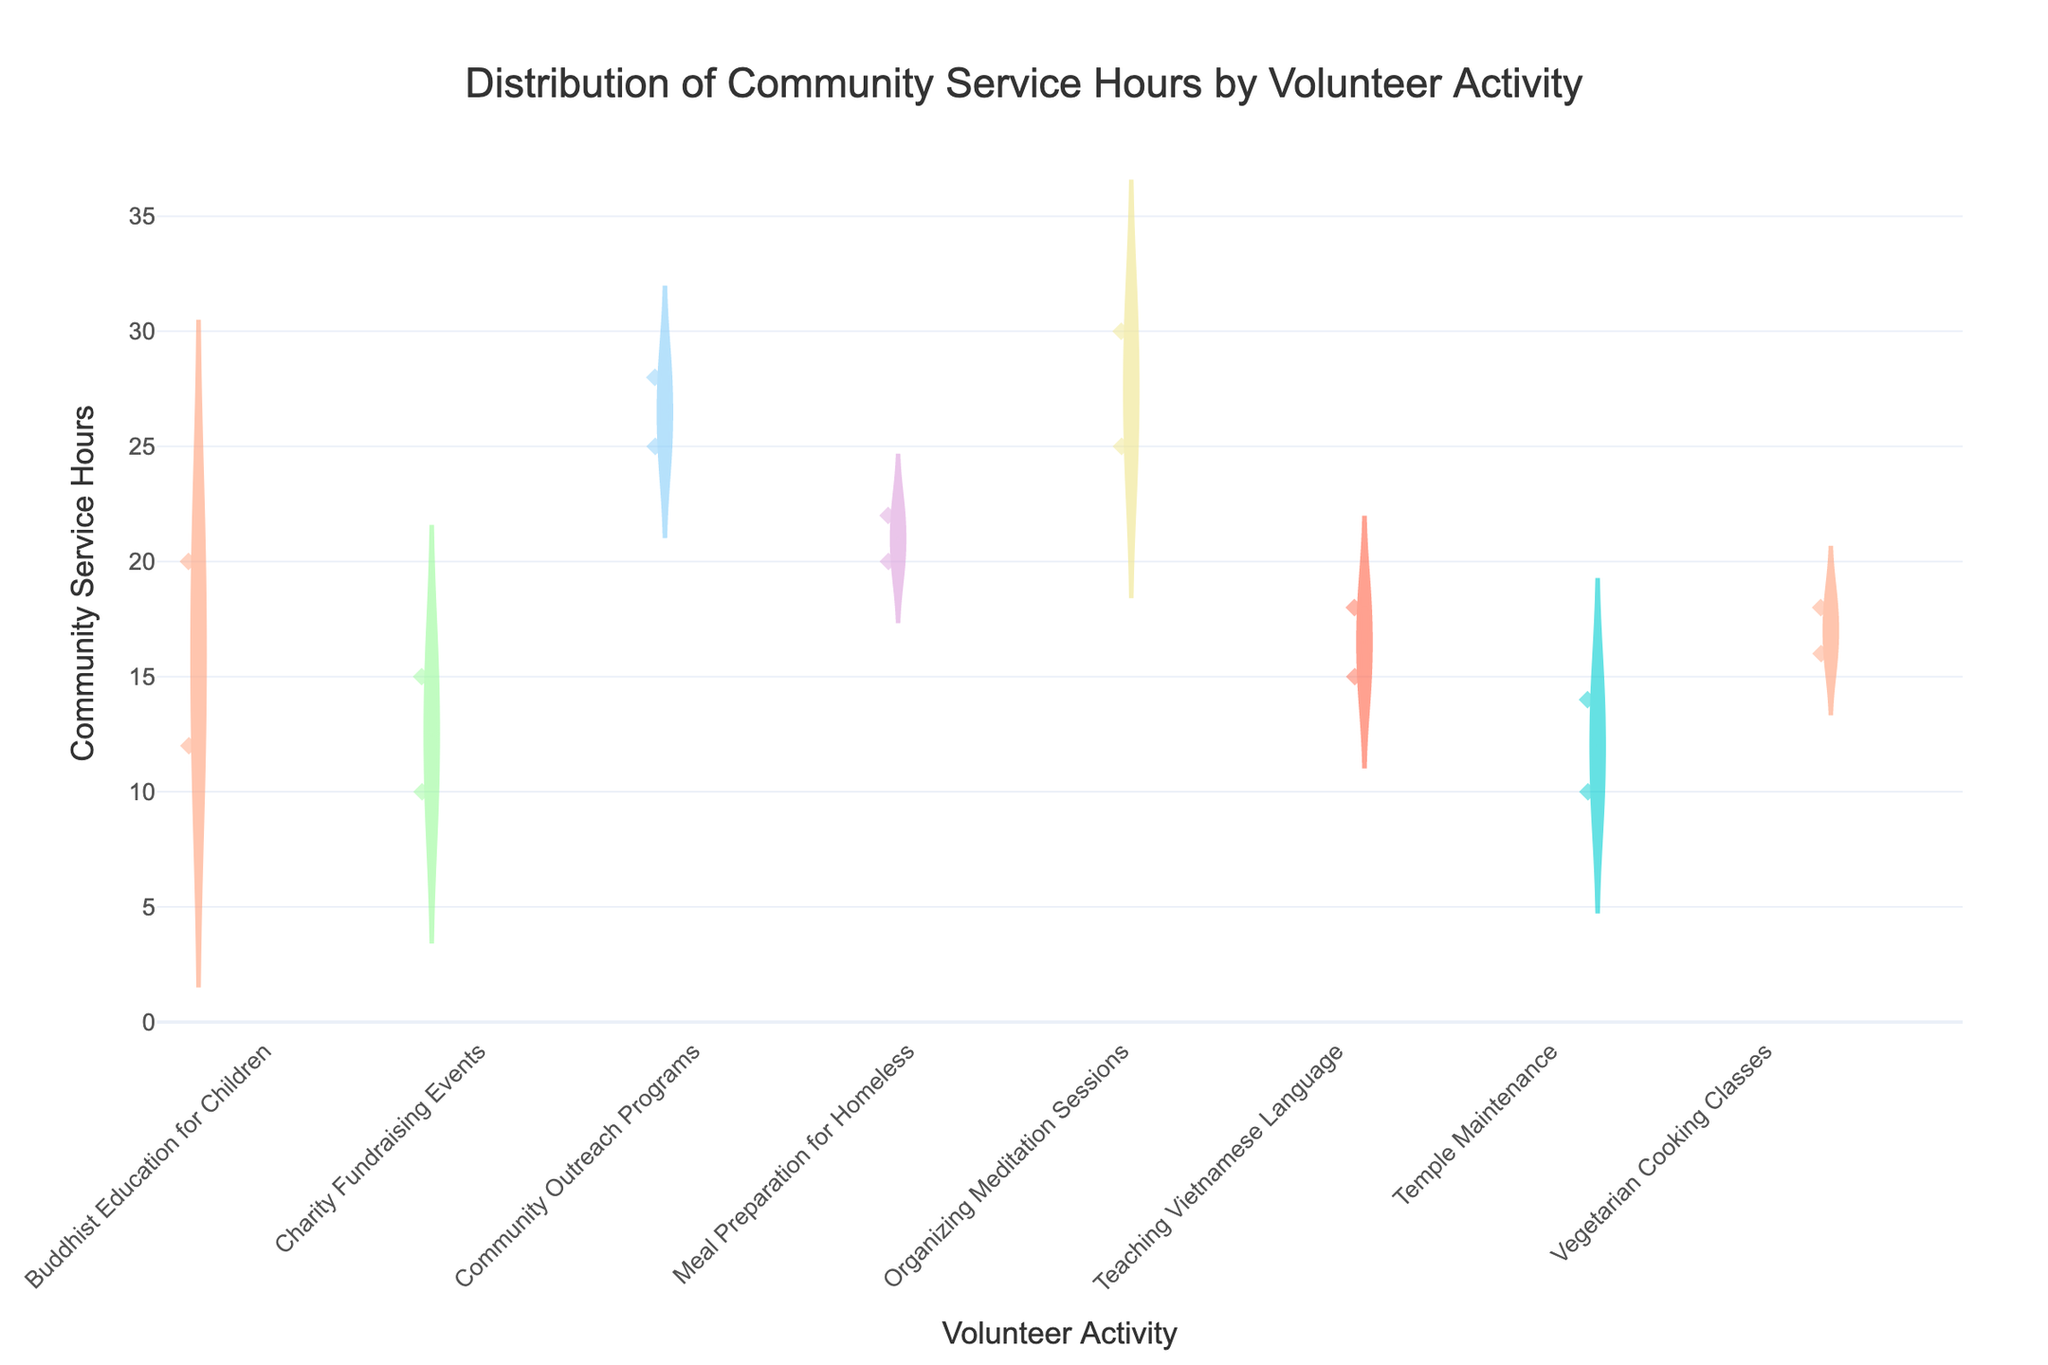Which volunteer activity has the highest median community service hours? By looking at the violin plots, the highest median is where the horizontal line in the middle of the violin is the highest.
Answer: Organizing Meditation Sessions Which volunteer activity has the widest range of community service hours? The range is determined by the length of the violin plot. The longer the plot, the wider the range of community service hours for that activity.
Answer: Community Outreach Programs How many data points are shown for Teaching Vietnamese Language? The number of data points corresponds to the number of diamonds visible in the violin plot for Teaching Vietnamese Language.
Answer: 2 Are there any outliers in the Community Outreach Programs activity? Outliers are usually depicted as separate points outside the main body of the violin plot. For Community Outreach Programs, we should look for points distinctly separated from others.
Answer: No Which volunteer activity appears to be the most consistent in terms of community service hours? Consistency can be gauged by how concentrated the data points are within the violin plot, i.e., a narrower plot.
Answer: Temple Maintenance What is the average community service hours for Meal Preparation for Homeless? By identifying the points for Meal Preparation for Homeless and calculating the average. There are 20 and 22 hours; so (20+22)/2 = 21.
Answer: 21 Is there a volunteer activity with only one available data point? A violin plot with a single diamond point indicates only one data point for that activity.
Answer: No Which volunteer activity has a median community service hour closest to 20 hours? The median is the line in the middle of the violin. By checking the median lines, we find the one closest to 20 hours.
Answer: Meal Preparation for Homeless Are there any volunteer activities where the quartiles are very close together? Quartiles are depicted by the thick central part of the violin plot. When this part is very narrow, it indicates quartiles are close.
Answer: Temple Maintenance Do all the violin plots show a symmetrical distribution of community service hours? Symmetry is indicated by how evenly the plots are shaped on both sides of the median line. For each plot, we should check if both sides are balanced.
Answer: No 